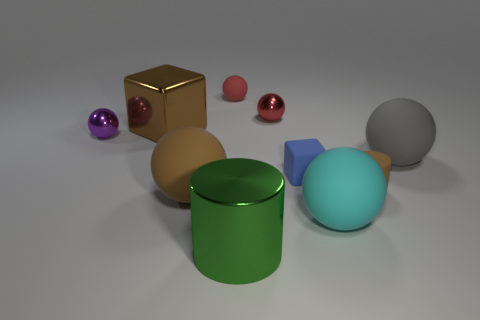What number of big red rubber objects are the same shape as the red metallic object?
Your answer should be compact. 0. There is a cylinder that is to the left of the large cyan matte sphere; what is its material?
Your answer should be very brief. Metal. Is the shape of the tiny shiny object that is to the right of the green metal thing the same as  the tiny brown rubber thing?
Provide a succinct answer. No. Are there any brown metallic things that have the same size as the blue object?
Ensure brevity in your answer.  No. There is a big brown shiny object; does it have the same shape as the tiny blue rubber thing that is in front of the gray object?
Give a very brief answer. Yes. The big rubber thing that is the same color as the metallic block is what shape?
Offer a very short reply. Sphere. Are there fewer large green cylinders behind the blue thing than big red cubes?
Offer a terse response. No. Does the gray object have the same shape as the purple metal object?
Your answer should be very brief. Yes. There is a brown ball that is made of the same material as the cyan ball; what size is it?
Make the answer very short. Large. Is the number of matte balls less than the number of blue matte objects?
Give a very brief answer. No. 